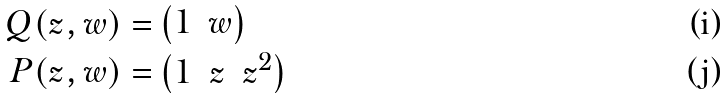Convert formula to latex. <formula><loc_0><loc_0><loc_500><loc_500>Q ( z , w ) = & \begin{pmatrix} 1 & w \end{pmatrix} \\ P ( z , w ) = & \begin{pmatrix} 1 & z & z ^ { 2 } \end{pmatrix}</formula> 